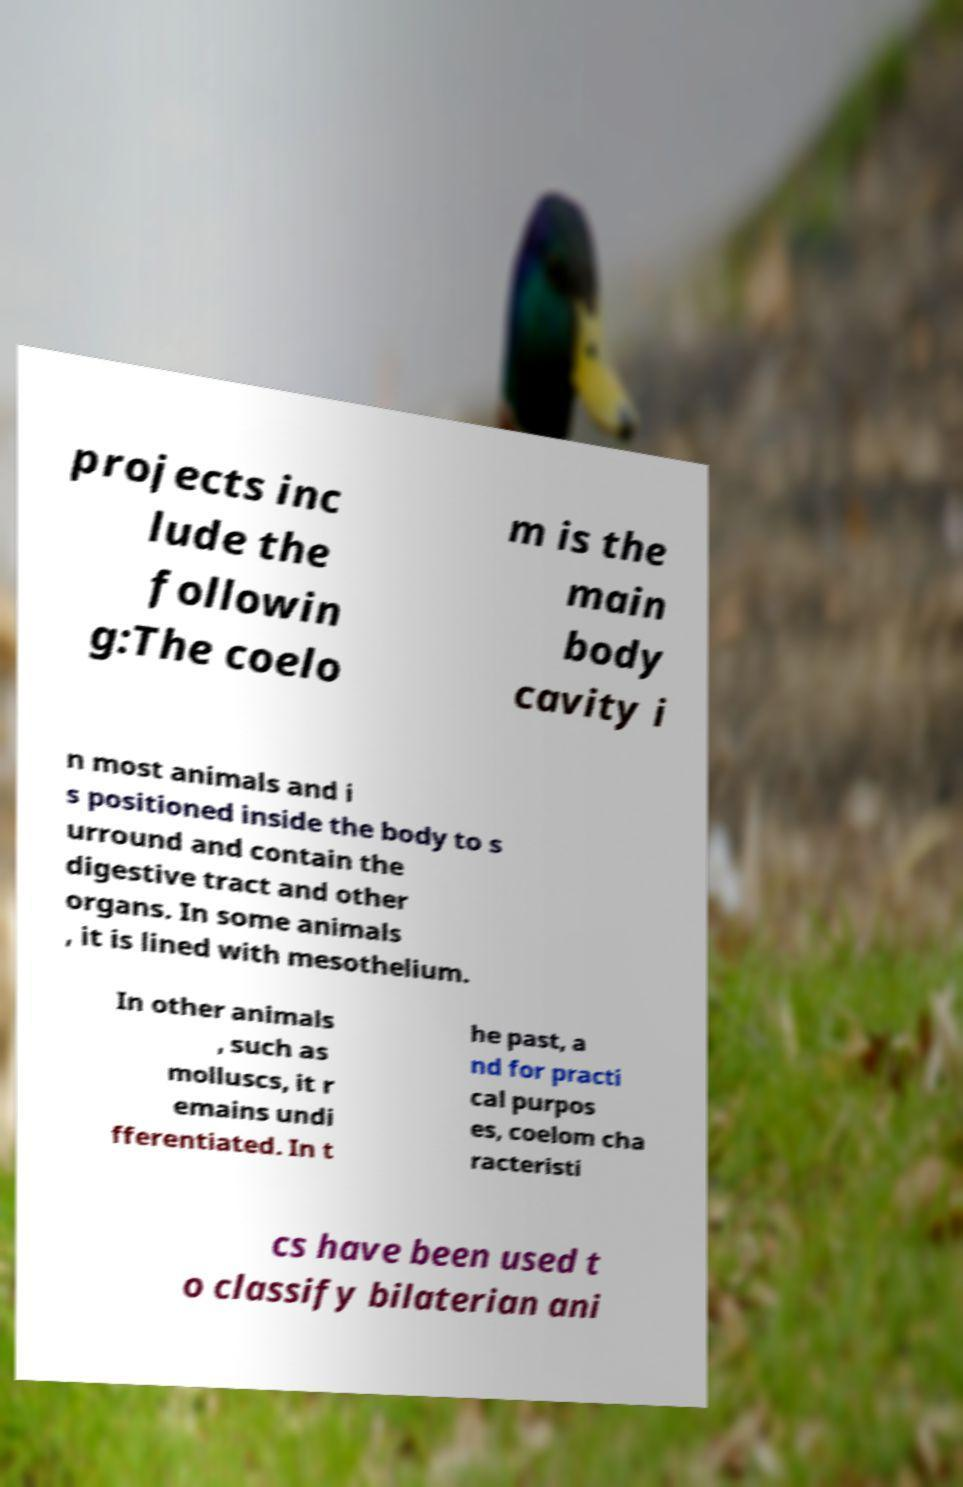Please identify and transcribe the text found in this image. projects inc lude the followin g:The coelo m is the main body cavity i n most animals and i s positioned inside the body to s urround and contain the digestive tract and other organs. In some animals , it is lined with mesothelium. In other animals , such as molluscs, it r emains undi fferentiated. In t he past, a nd for practi cal purpos es, coelom cha racteristi cs have been used t o classify bilaterian ani 